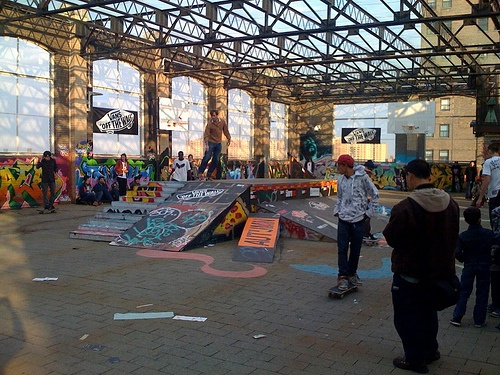Describe the objects in this image and their specific colors. I can see people in black and gray tones, people in black, gray, and maroon tones, people in black, gray, and purple tones, people in black, gray, and maroon tones, and people in black, maroon, and brown tones in this image. 